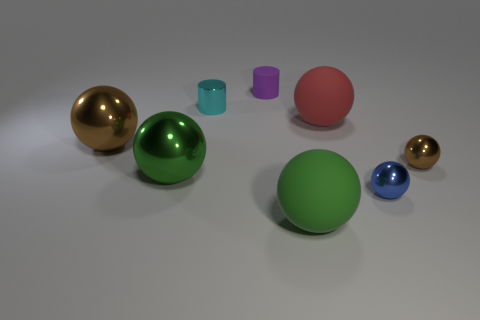Subtract 1 spheres. How many spheres are left? 5 Subtract all red balls. How many balls are left? 5 Subtract all large shiny balls. How many balls are left? 4 Subtract all cyan balls. Subtract all cyan blocks. How many balls are left? 6 Add 1 blue metallic balls. How many objects exist? 9 Subtract all spheres. How many objects are left? 2 Add 3 small purple rubber objects. How many small purple rubber objects are left? 4 Add 1 matte cylinders. How many matte cylinders exist? 2 Subtract 0 green cylinders. How many objects are left? 8 Subtract all tiny objects. Subtract all blue spheres. How many objects are left? 3 